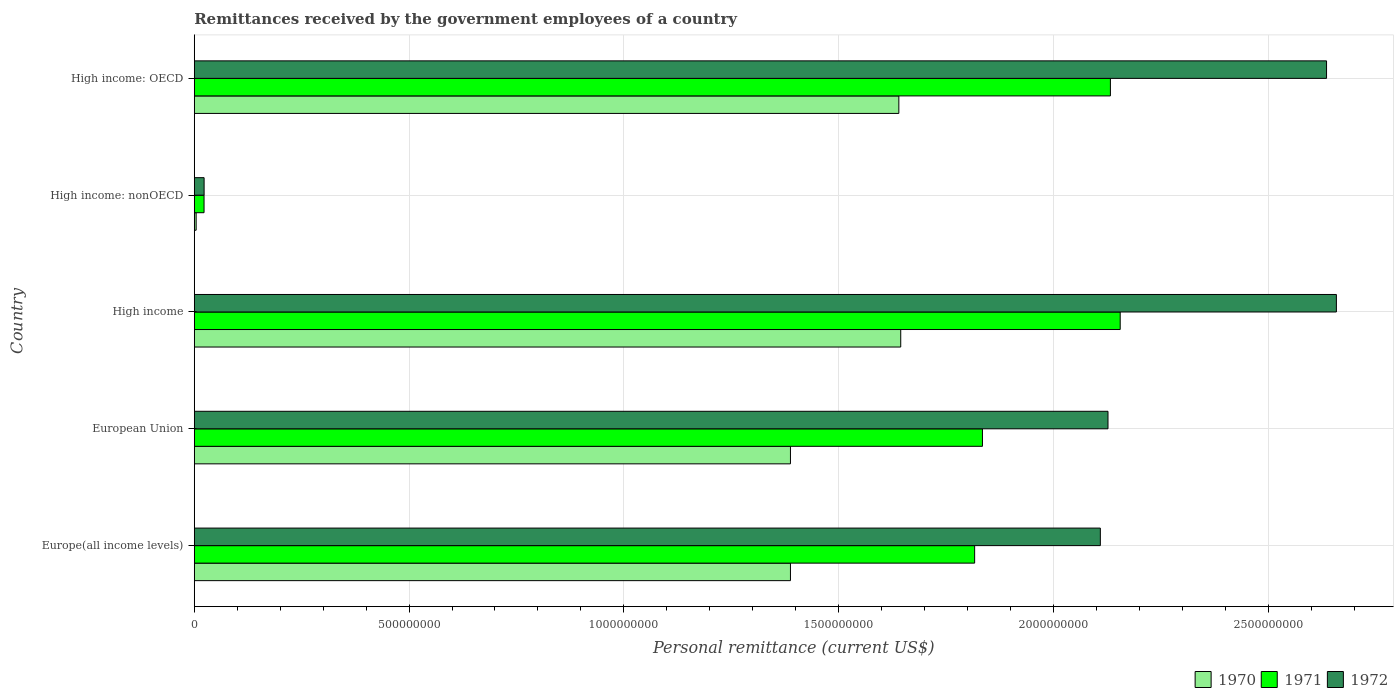How many different coloured bars are there?
Offer a terse response. 3. Are the number of bars per tick equal to the number of legend labels?
Ensure brevity in your answer.  Yes. What is the label of the 2nd group of bars from the top?
Offer a very short reply. High income: nonOECD. In how many cases, is the number of bars for a given country not equal to the number of legend labels?
Your answer should be very brief. 0. What is the remittances received by the government employees in 1970 in European Union?
Provide a succinct answer. 1.39e+09. Across all countries, what is the maximum remittances received by the government employees in 1972?
Make the answer very short. 2.66e+09. Across all countries, what is the minimum remittances received by the government employees in 1970?
Your answer should be very brief. 4.40e+06. In which country was the remittances received by the government employees in 1970 minimum?
Ensure brevity in your answer.  High income: nonOECD. What is the total remittances received by the government employees in 1970 in the graph?
Offer a terse response. 6.06e+09. What is the difference between the remittances received by the government employees in 1970 in Europe(all income levels) and that in High income: OECD?
Your response must be concise. -2.52e+08. What is the difference between the remittances received by the government employees in 1971 in High income and the remittances received by the government employees in 1972 in European Union?
Provide a short and direct response. 2.84e+07. What is the average remittances received by the government employees in 1970 per country?
Your response must be concise. 1.21e+09. What is the difference between the remittances received by the government employees in 1971 and remittances received by the government employees in 1970 in European Union?
Offer a very short reply. 4.47e+08. In how many countries, is the remittances received by the government employees in 1971 greater than 200000000 US$?
Make the answer very short. 4. What is the ratio of the remittances received by the government employees in 1970 in High income to that in High income: OECD?
Provide a short and direct response. 1. Is the remittances received by the government employees in 1970 in High income less than that in High income: nonOECD?
Keep it short and to the point. No. Is the difference between the remittances received by the government employees in 1971 in High income: OECD and High income: nonOECD greater than the difference between the remittances received by the government employees in 1970 in High income: OECD and High income: nonOECD?
Your answer should be very brief. Yes. What is the difference between the highest and the second highest remittances received by the government employees in 1972?
Provide a succinct answer. 2.29e+07. What is the difference between the highest and the lowest remittances received by the government employees in 1970?
Provide a succinct answer. 1.64e+09. Are all the bars in the graph horizontal?
Ensure brevity in your answer.  Yes. How many countries are there in the graph?
Your answer should be very brief. 5. What is the difference between two consecutive major ticks on the X-axis?
Offer a terse response. 5.00e+08. Are the values on the major ticks of X-axis written in scientific E-notation?
Offer a very short reply. No. Does the graph contain any zero values?
Make the answer very short. No. How many legend labels are there?
Keep it short and to the point. 3. What is the title of the graph?
Make the answer very short. Remittances received by the government employees of a country. Does "1965" appear as one of the legend labels in the graph?
Your response must be concise. No. What is the label or title of the X-axis?
Make the answer very short. Personal remittance (current US$). What is the label or title of the Y-axis?
Give a very brief answer. Country. What is the Personal remittance (current US$) of 1970 in Europe(all income levels)?
Your response must be concise. 1.39e+09. What is the Personal remittance (current US$) of 1971 in Europe(all income levels)?
Make the answer very short. 1.82e+09. What is the Personal remittance (current US$) in 1972 in Europe(all income levels)?
Offer a terse response. 2.11e+09. What is the Personal remittance (current US$) in 1970 in European Union?
Your answer should be very brief. 1.39e+09. What is the Personal remittance (current US$) in 1971 in European Union?
Offer a very short reply. 1.83e+09. What is the Personal remittance (current US$) of 1972 in European Union?
Give a very brief answer. 2.13e+09. What is the Personal remittance (current US$) in 1970 in High income?
Give a very brief answer. 1.64e+09. What is the Personal remittance (current US$) of 1971 in High income?
Give a very brief answer. 2.16e+09. What is the Personal remittance (current US$) of 1972 in High income?
Your answer should be very brief. 2.66e+09. What is the Personal remittance (current US$) in 1970 in High income: nonOECD?
Your answer should be compact. 4.40e+06. What is the Personal remittance (current US$) of 1971 in High income: nonOECD?
Provide a short and direct response. 2.28e+07. What is the Personal remittance (current US$) in 1972 in High income: nonOECD?
Keep it short and to the point. 2.29e+07. What is the Personal remittance (current US$) of 1970 in High income: OECD?
Keep it short and to the point. 1.64e+09. What is the Personal remittance (current US$) in 1971 in High income: OECD?
Your answer should be very brief. 2.13e+09. What is the Personal remittance (current US$) in 1972 in High income: OECD?
Your answer should be very brief. 2.64e+09. Across all countries, what is the maximum Personal remittance (current US$) of 1970?
Provide a succinct answer. 1.64e+09. Across all countries, what is the maximum Personal remittance (current US$) in 1971?
Offer a terse response. 2.16e+09. Across all countries, what is the maximum Personal remittance (current US$) in 1972?
Give a very brief answer. 2.66e+09. Across all countries, what is the minimum Personal remittance (current US$) of 1970?
Make the answer very short. 4.40e+06. Across all countries, what is the minimum Personal remittance (current US$) in 1971?
Keep it short and to the point. 2.28e+07. Across all countries, what is the minimum Personal remittance (current US$) of 1972?
Make the answer very short. 2.29e+07. What is the total Personal remittance (current US$) of 1970 in the graph?
Offer a very short reply. 6.06e+09. What is the total Personal remittance (current US$) in 1971 in the graph?
Your answer should be very brief. 7.96e+09. What is the total Personal remittance (current US$) in 1972 in the graph?
Provide a short and direct response. 9.55e+09. What is the difference between the Personal remittance (current US$) in 1971 in Europe(all income levels) and that in European Union?
Your answer should be compact. -1.82e+07. What is the difference between the Personal remittance (current US$) of 1972 in Europe(all income levels) and that in European Union?
Offer a very short reply. -1.78e+07. What is the difference between the Personal remittance (current US$) of 1970 in Europe(all income levels) and that in High income?
Offer a very short reply. -2.57e+08. What is the difference between the Personal remittance (current US$) of 1971 in Europe(all income levels) and that in High income?
Keep it short and to the point. -3.39e+08. What is the difference between the Personal remittance (current US$) in 1972 in Europe(all income levels) and that in High income?
Provide a succinct answer. -5.49e+08. What is the difference between the Personal remittance (current US$) in 1970 in Europe(all income levels) and that in High income: nonOECD?
Your answer should be very brief. 1.38e+09. What is the difference between the Personal remittance (current US$) of 1971 in Europe(all income levels) and that in High income: nonOECD?
Provide a short and direct response. 1.79e+09. What is the difference between the Personal remittance (current US$) of 1972 in Europe(all income levels) and that in High income: nonOECD?
Your answer should be very brief. 2.09e+09. What is the difference between the Personal remittance (current US$) of 1970 in Europe(all income levels) and that in High income: OECD?
Your answer should be very brief. -2.52e+08. What is the difference between the Personal remittance (current US$) of 1971 in Europe(all income levels) and that in High income: OECD?
Ensure brevity in your answer.  -3.16e+08. What is the difference between the Personal remittance (current US$) in 1972 in Europe(all income levels) and that in High income: OECD?
Provide a short and direct response. -5.27e+08. What is the difference between the Personal remittance (current US$) in 1970 in European Union and that in High income?
Offer a terse response. -2.57e+08. What is the difference between the Personal remittance (current US$) of 1971 in European Union and that in High income?
Your response must be concise. -3.21e+08. What is the difference between the Personal remittance (current US$) of 1972 in European Union and that in High income?
Keep it short and to the point. -5.32e+08. What is the difference between the Personal remittance (current US$) of 1970 in European Union and that in High income: nonOECD?
Your answer should be compact. 1.38e+09. What is the difference between the Personal remittance (current US$) of 1971 in European Union and that in High income: nonOECD?
Make the answer very short. 1.81e+09. What is the difference between the Personal remittance (current US$) of 1972 in European Union and that in High income: nonOECD?
Provide a short and direct response. 2.10e+09. What is the difference between the Personal remittance (current US$) of 1970 in European Union and that in High income: OECD?
Ensure brevity in your answer.  -2.52e+08. What is the difference between the Personal remittance (current US$) in 1971 in European Union and that in High income: OECD?
Provide a short and direct response. -2.98e+08. What is the difference between the Personal remittance (current US$) in 1972 in European Union and that in High income: OECD?
Your answer should be compact. -5.09e+08. What is the difference between the Personal remittance (current US$) in 1970 in High income and that in High income: nonOECD?
Keep it short and to the point. 1.64e+09. What is the difference between the Personal remittance (current US$) of 1971 in High income and that in High income: nonOECD?
Offer a very short reply. 2.13e+09. What is the difference between the Personal remittance (current US$) in 1972 in High income and that in High income: nonOECD?
Keep it short and to the point. 2.64e+09. What is the difference between the Personal remittance (current US$) in 1970 in High income and that in High income: OECD?
Make the answer very short. 4.40e+06. What is the difference between the Personal remittance (current US$) of 1971 in High income and that in High income: OECD?
Keep it short and to the point. 2.28e+07. What is the difference between the Personal remittance (current US$) of 1972 in High income and that in High income: OECD?
Give a very brief answer. 2.29e+07. What is the difference between the Personal remittance (current US$) of 1970 in High income: nonOECD and that in High income: OECD?
Your answer should be very brief. -1.64e+09. What is the difference between the Personal remittance (current US$) in 1971 in High income: nonOECD and that in High income: OECD?
Your answer should be very brief. -2.11e+09. What is the difference between the Personal remittance (current US$) in 1972 in High income: nonOECD and that in High income: OECD?
Provide a succinct answer. -2.61e+09. What is the difference between the Personal remittance (current US$) in 1970 in Europe(all income levels) and the Personal remittance (current US$) in 1971 in European Union?
Your answer should be very brief. -4.47e+08. What is the difference between the Personal remittance (current US$) in 1970 in Europe(all income levels) and the Personal remittance (current US$) in 1972 in European Union?
Give a very brief answer. -7.39e+08. What is the difference between the Personal remittance (current US$) of 1971 in Europe(all income levels) and the Personal remittance (current US$) of 1972 in European Union?
Ensure brevity in your answer.  -3.10e+08. What is the difference between the Personal remittance (current US$) of 1970 in Europe(all income levels) and the Personal remittance (current US$) of 1971 in High income?
Ensure brevity in your answer.  -7.68e+08. What is the difference between the Personal remittance (current US$) of 1970 in Europe(all income levels) and the Personal remittance (current US$) of 1972 in High income?
Offer a very short reply. -1.27e+09. What is the difference between the Personal remittance (current US$) of 1971 in Europe(all income levels) and the Personal remittance (current US$) of 1972 in High income?
Provide a short and direct response. -8.42e+08. What is the difference between the Personal remittance (current US$) of 1970 in Europe(all income levels) and the Personal remittance (current US$) of 1971 in High income: nonOECD?
Your response must be concise. 1.37e+09. What is the difference between the Personal remittance (current US$) of 1970 in Europe(all income levels) and the Personal remittance (current US$) of 1972 in High income: nonOECD?
Ensure brevity in your answer.  1.36e+09. What is the difference between the Personal remittance (current US$) of 1971 in Europe(all income levels) and the Personal remittance (current US$) of 1972 in High income: nonOECD?
Keep it short and to the point. 1.79e+09. What is the difference between the Personal remittance (current US$) in 1970 in Europe(all income levels) and the Personal remittance (current US$) in 1971 in High income: OECD?
Give a very brief answer. -7.45e+08. What is the difference between the Personal remittance (current US$) of 1970 in Europe(all income levels) and the Personal remittance (current US$) of 1972 in High income: OECD?
Your answer should be compact. -1.25e+09. What is the difference between the Personal remittance (current US$) in 1971 in Europe(all income levels) and the Personal remittance (current US$) in 1972 in High income: OECD?
Provide a short and direct response. -8.19e+08. What is the difference between the Personal remittance (current US$) in 1970 in European Union and the Personal remittance (current US$) in 1971 in High income?
Give a very brief answer. -7.68e+08. What is the difference between the Personal remittance (current US$) in 1970 in European Union and the Personal remittance (current US$) in 1972 in High income?
Provide a short and direct response. -1.27e+09. What is the difference between the Personal remittance (current US$) in 1971 in European Union and the Personal remittance (current US$) in 1972 in High income?
Offer a terse response. -8.24e+08. What is the difference between the Personal remittance (current US$) in 1970 in European Union and the Personal remittance (current US$) in 1971 in High income: nonOECD?
Offer a very short reply. 1.37e+09. What is the difference between the Personal remittance (current US$) in 1970 in European Union and the Personal remittance (current US$) in 1972 in High income: nonOECD?
Give a very brief answer. 1.36e+09. What is the difference between the Personal remittance (current US$) in 1971 in European Union and the Personal remittance (current US$) in 1972 in High income: nonOECD?
Your response must be concise. 1.81e+09. What is the difference between the Personal remittance (current US$) of 1970 in European Union and the Personal remittance (current US$) of 1971 in High income: OECD?
Your response must be concise. -7.45e+08. What is the difference between the Personal remittance (current US$) of 1970 in European Union and the Personal remittance (current US$) of 1972 in High income: OECD?
Offer a terse response. -1.25e+09. What is the difference between the Personal remittance (current US$) in 1971 in European Union and the Personal remittance (current US$) in 1972 in High income: OECD?
Your response must be concise. -8.01e+08. What is the difference between the Personal remittance (current US$) in 1970 in High income and the Personal remittance (current US$) in 1971 in High income: nonOECD?
Give a very brief answer. 1.62e+09. What is the difference between the Personal remittance (current US$) in 1970 in High income and the Personal remittance (current US$) in 1972 in High income: nonOECD?
Give a very brief answer. 1.62e+09. What is the difference between the Personal remittance (current US$) of 1971 in High income and the Personal remittance (current US$) of 1972 in High income: nonOECD?
Your response must be concise. 2.13e+09. What is the difference between the Personal remittance (current US$) of 1970 in High income and the Personal remittance (current US$) of 1971 in High income: OECD?
Provide a short and direct response. -4.88e+08. What is the difference between the Personal remittance (current US$) in 1970 in High income and the Personal remittance (current US$) in 1972 in High income: OECD?
Your answer should be very brief. -9.91e+08. What is the difference between the Personal remittance (current US$) in 1971 in High income and the Personal remittance (current US$) in 1972 in High income: OECD?
Keep it short and to the point. -4.80e+08. What is the difference between the Personal remittance (current US$) in 1970 in High income: nonOECD and the Personal remittance (current US$) in 1971 in High income: OECD?
Provide a succinct answer. -2.13e+09. What is the difference between the Personal remittance (current US$) of 1970 in High income: nonOECD and the Personal remittance (current US$) of 1972 in High income: OECD?
Offer a terse response. -2.63e+09. What is the difference between the Personal remittance (current US$) in 1971 in High income: nonOECD and the Personal remittance (current US$) in 1972 in High income: OECD?
Offer a very short reply. -2.61e+09. What is the average Personal remittance (current US$) of 1970 per country?
Offer a terse response. 1.21e+09. What is the average Personal remittance (current US$) in 1971 per country?
Offer a terse response. 1.59e+09. What is the average Personal remittance (current US$) in 1972 per country?
Offer a very short reply. 1.91e+09. What is the difference between the Personal remittance (current US$) of 1970 and Personal remittance (current US$) of 1971 in Europe(all income levels)?
Give a very brief answer. -4.29e+08. What is the difference between the Personal remittance (current US$) of 1970 and Personal remittance (current US$) of 1972 in Europe(all income levels)?
Provide a succinct answer. -7.21e+08. What is the difference between the Personal remittance (current US$) in 1971 and Personal remittance (current US$) in 1972 in Europe(all income levels)?
Your answer should be very brief. -2.93e+08. What is the difference between the Personal remittance (current US$) in 1970 and Personal remittance (current US$) in 1971 in European Union?
Provide a short and direct response. -4.47e+08. What is the difference between the Personal remittance (current US$) of 1970 and Personal remittance (current US$) of 1972 in European Union?
Make the answer very short. -7.39e+08. What is the difference between the Personal remittance (current US$) of 1971 and Personal remittance (current US$) of 1972 in European Union?
Provide a succinct answer. -2.92e+08. What is the difference between the Personal remittance (current US$) of 1970 and Personal remittance (current US$) of 1971 in High income?
Provide a succinct answer. -5.11e+08. What is the difference between the Personal remittance (current US$) in 1970 and Personal remittance (current US$) in 1972 in High income?
Your response must be concise. -1.01e+09. What is the difference between the Personal remittance (current US$) in 1971 and Personal remittance (current US$) in 1972 in High income?
Your answer should be compact. -5.03e+08. What is the difference between the Personal remittance (current US$) in 1970 and Personal remittance (current US$) in 1971 in High income: nonOECD?
Make the answer very short. -1.84e+07. What is the difference between the Personal remittance (current US$) of 1970 and Personal remittance (current US$) of 1972 in High income: nonOECD?
Your response must be concise. -1.85e+07. What is the difference between the Personal remittance (current US$) of 1971 and Personal remittance (current US$) of 1972 in High income: nonOECD?
Provide a short and direct response. -1.37e+05. What is the difference between the Personal remittance (current US$) in 1970 and Personal remittance (current US$) in 1971 in High income: OECD?
Give a very brief answer. -4.92e+08. What is the difference between the Personal remittance (current US$) of 1970 and Personal remittance (current US$) of 1972 in High income: OECD?
Ensure brevity in your answer.  -9.96e+08. What is the difference between the Personal remittance (current US$) in 1971 and Personal remittance (current US$) in 1972 in High income: OECD?
Provide a short and direct response. -5.03e+08. What is the ratio of the Personal remittance (current US$) of 1971 in Europe(all income levels) to that in European Union?
Ensure brevity in your answer.  0.99. What is the ratio of the Personal remittance (current US$) in 1970 in Europe(all income levels) to that in High income?
Ensure brevity in your answer.  0.84. What is the ratio of the Personal remittance (current US$) of 1971 in Europe(all income levels) to that in High income?
Give a very brief answer. 0.84. What is the ratio of the Personal remittance (current US$) in 1972 in Europe(all income levels) to that in High income?
Your response must be concise. 0.79. What is the ratio of the Personal remittance (current US$) in 1970 in Europe(all income levels) to that in High income: nonOECD?
Provide a short and direct response. 315.41. What is the ratio of the Personal remittance (current US$) in 1971 in Europe(all income levels) to that in High income: nonOECD?
Offer a very short reply. 79.73. What is the ratio of the Personal remittance (current US$) of 1972 in Europe(all income levels) to that in High income: nonOECD?
Offer a very short reply. 92.02. What is the ratio of the Personal remittance (current US$) in 1970 in Europe(all income levels) to that in High income: OECD?
Provide a succinct answer. 0.85. What is the ratio of the Personal remittance (current US$) of 1971 in Europe(all income levels) to that in High income: OECD?
Keep it short and to the point. 0.85. What is the ratio of the Personal remittance (current US$) in 1972 in Europe(all income levels) to that in High income: OECD?
Offer a very short reply. 0.8. What is the ratio of the Personal remittance (current US$) in 1970 in European Union to that in High income?
Offer a very short reply. 0.84. What is the ratio of the Personal remittance (current US$) of 1971 in European Union to that in High income?
Provide a succinct answer. 0.85. What is the ratio of the Personal remittance (current US$) of 1970 in European Union to that in High income: nonOECD?
Your response must be concise. 315.41. What is the ratio of the Personal remittance (current US$) in 1971 in European Union to that in High income: nonOECD?
Your answer should be very brief. 80.52. What is the ratio of the Personal remittance (current US$) of 1972 in European Union to that in High income: nonOECD?
Ensure brevity in your answer.  92.79. What is the ratio of the Personal remittance (current US$) of 1970 in European Union to that in High income: OECD?
Your answer should be compact. 0.85. What is the ratio of the Personal remittance (current US$) in 1971 in European Union to that in High income: OECD?
Your response must be concise. 0.86. What is the ratio of the Personal remittance (current US$) of 1972 in European Union to that in High income: OECD?
Your answer should be compact. 0.81. What is the ratio of the Personal remittance (current US$) in 1970 in High income to that in High income: nonOECD?
Make the answer very short. 373.75. What is the ratio of the Personal remittance (current US$) in 1971 in High income to that in High income: nonOECD?
Offer a terse response. 94.6. What is the ratio of the Personal remittance (current US$) of 1972 in High income to that in High income: nonOECD?
Your answer should be compact. 115.99. What is the ratio of the Personal remittance (current US$) in 1971 in High income to that in High income: OECD?
Give a very brief answer. 1.01. What is the ratio of the Personal remittance (current US$) in 1972 in High income to that in High income: OECD?
Keep it short and to the point. 1.01. What is the ratio of the Personal remittance (current US$) of 1970 in High income: nonOECD to that in High income: OECD?
Your answer should be very brief. 0. What is the ratio of the Personal remittance (current US$) in 1971 in High income: nonOECD to that in High income: OECD?
Keep it short and to the point. 0.01. What is the ratio of the Personal remittance (current US$) in 1972 in High income: nonOECD to that in High income: OECD?
Provide a short and direct response. 0.01. What is the difference between the highest and the second highest Personal remittance (current US$) of 1970?
Ensure brevity in your answer.  4.40e+06. What is the difference between the highest and the second highest Personal remittance (current US$) in 1971?
Your answer should be very brief. 2.28e+07. What is the difference between the highest and the second highest Personal remittance (current US$) in 1972?
Provide a short and direct response. 2.29e+07. What is the difference between the highest and the lowest Personal remittance (current US$) in 1970?
Ensure brevity in your answer.  1.64e+09. What is the difference between the highest and the lowest Personal remittance (current US$) of 1971?
Offer a terse response. 2.13e+09. What is the difference between the highest and the lowest Personal remittance (current US$) of 1972?
Provide a short and direct response. 2.64e+09. 